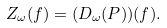<formula> <loc_0><loc_0><loc_500><loc_500>Z _ { \omega } ( f ) = ( D _ { \omega } ( P ) ) ( f ) .</formula> 